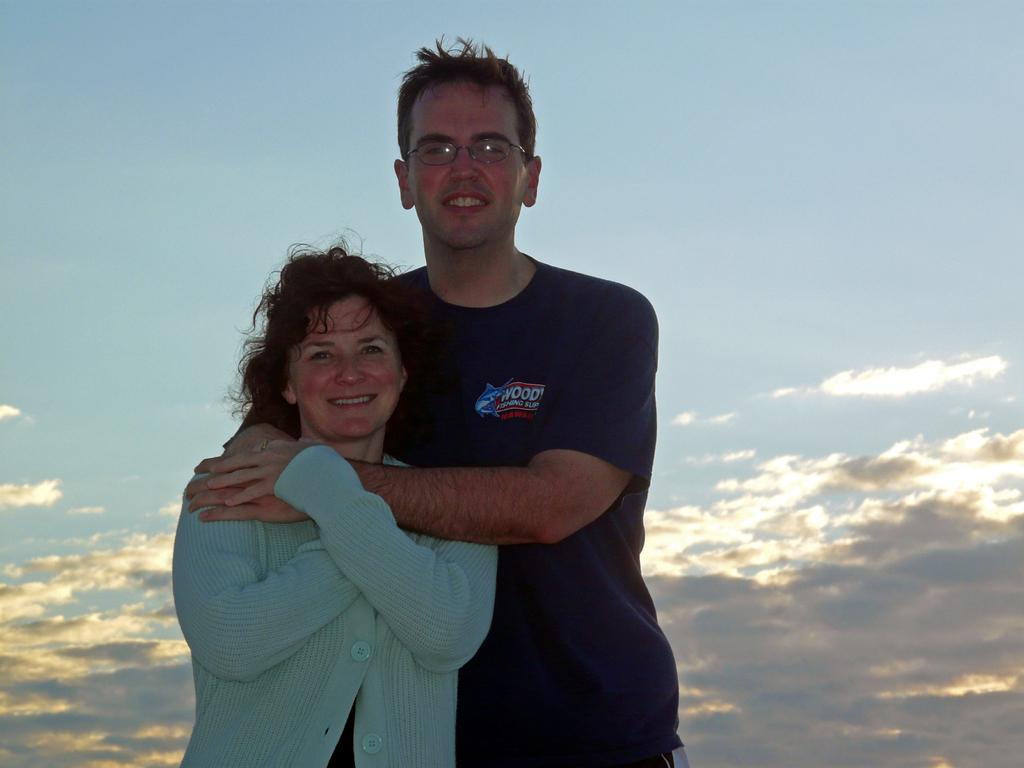How many people are present in the image? There are two people, a man and a woman, present in the image. What is the man doing in the image? The man is holding the woman in the image. What can be seen in the background of the image? The sky is visible in the background of the image. What type of wrench is the man using to fix the hall in the image? There is no wrench or hall present in the image; it features a man holding a woman with the sky visible in the background. 